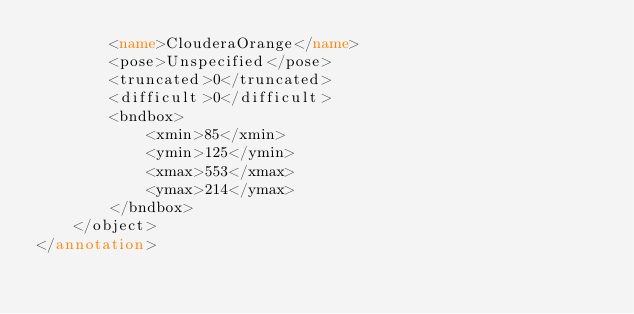<code> <loc_0><loc_0><loc_500><loc_500><_XML_>		<name>ClouderaOrange</name>
		<pose>Unspecified</pose>
		<truncated>0</truncated>
		<difficult>0</difficult>
		<bndbox>
			<xmin>85</xmin>
			<ymin>125</ymin>
			<xmax>553</xmax>
			<ymax>214</ymax>
		</bndbox>
	</object>
</annotation>
</code> 